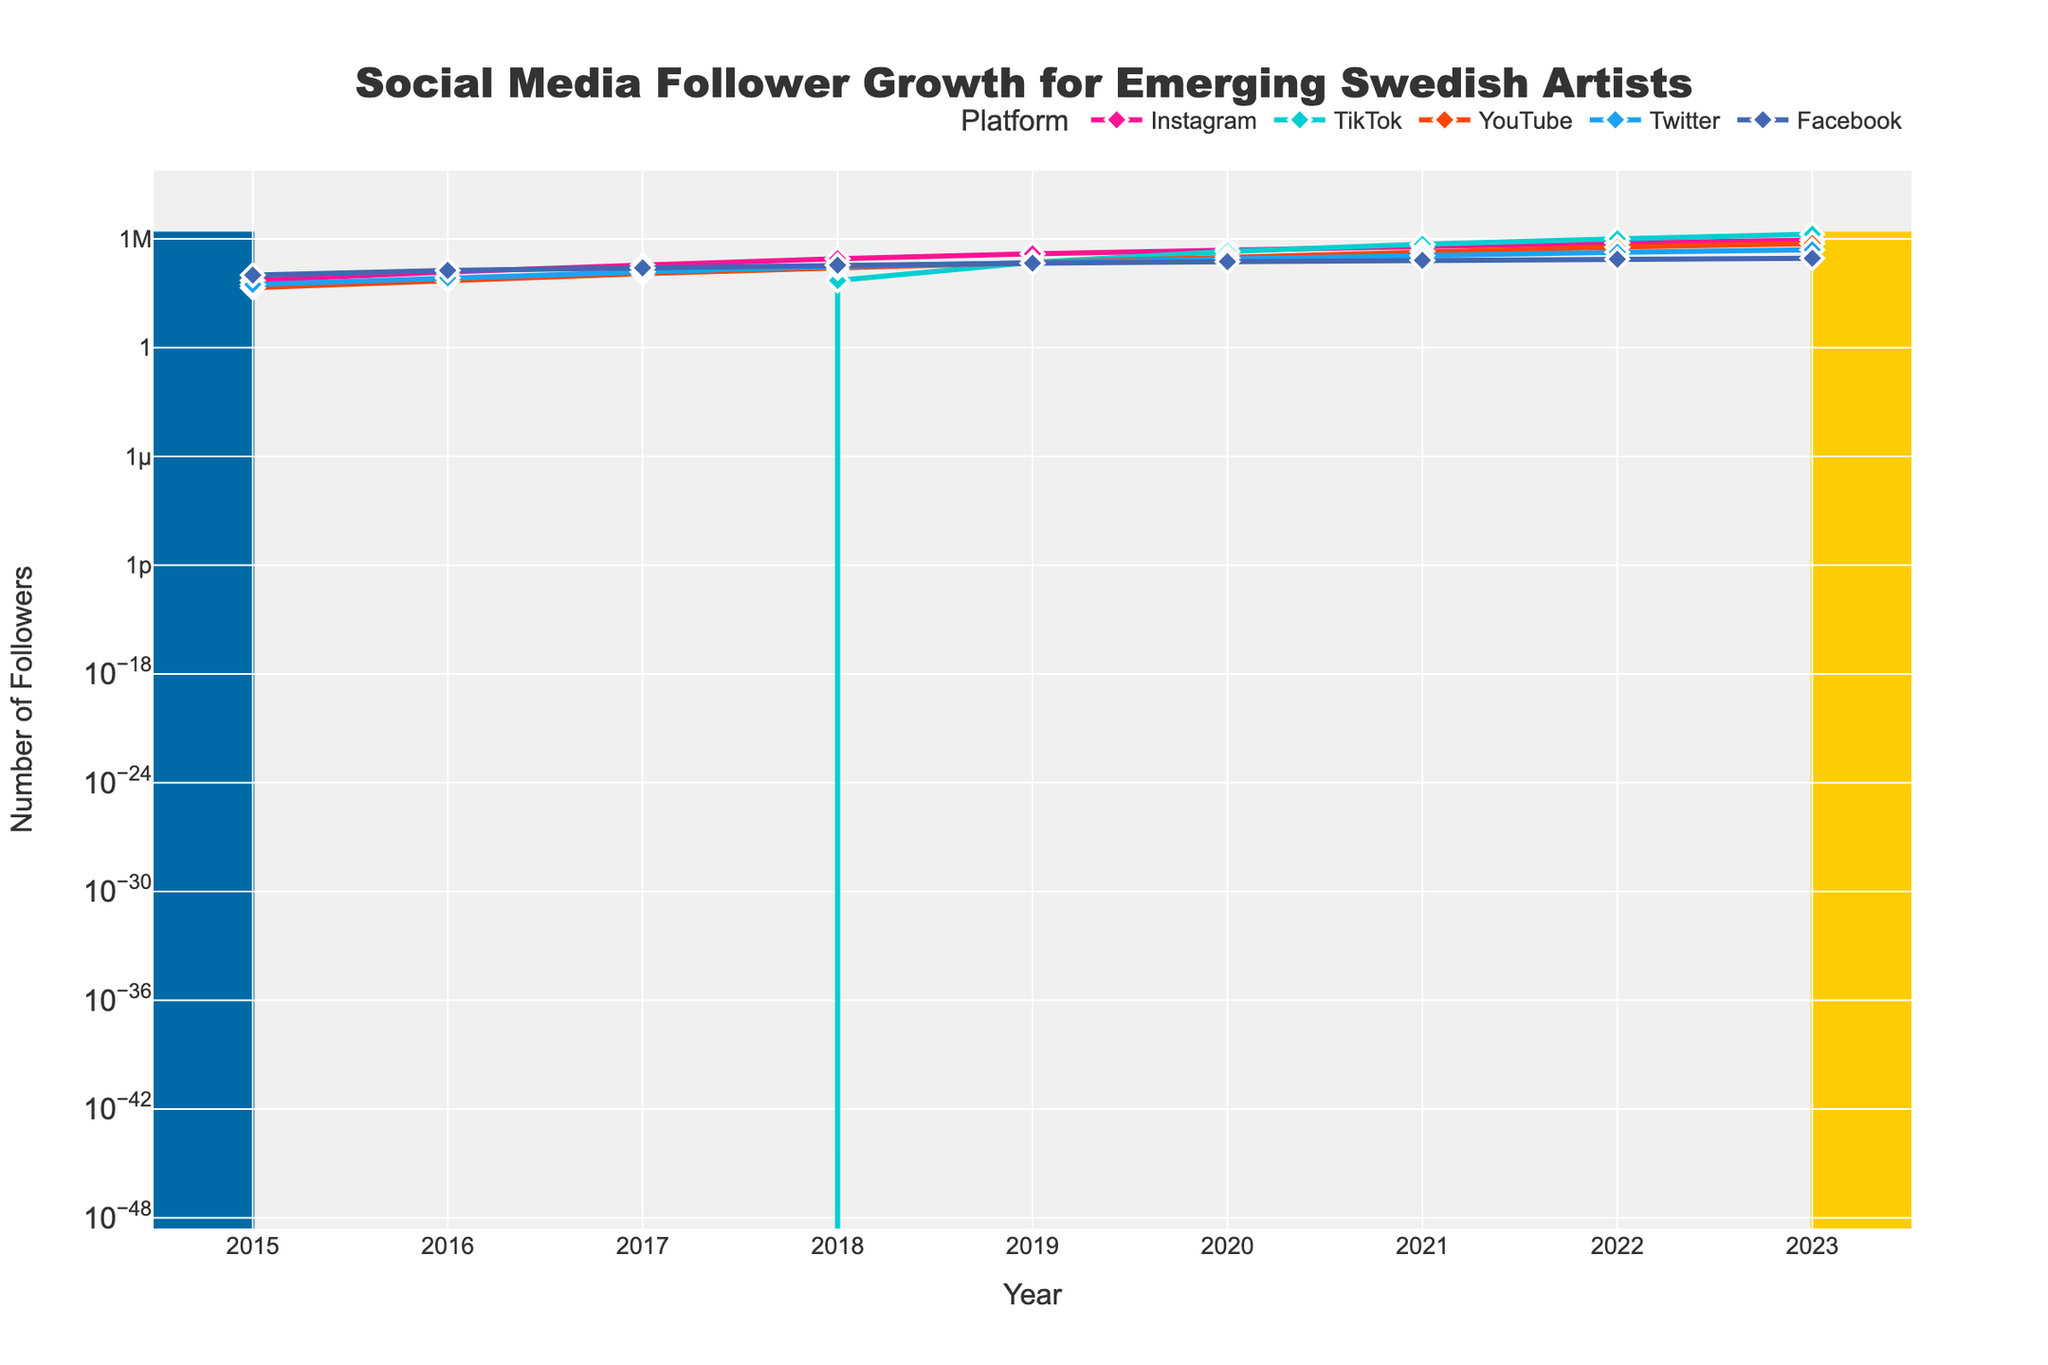What year did TikTok surpass Instagram in followers? By observing the graph, the point where the TikTok line crosses above the Instagram line signifies TikTok surpassing Instagram in followers. This crossover occurs between 2021 and 2022.
Answer: 2022 Which social media platform had the highest growth rate between 2018 and 2019? Examining the slope of the lines between 2018 and 2019, TikTok shows the steepest increase in followers, indicating the highest growth rate during that period.
Answer: TikTok By how much did YouTube followers increase from 2015 to 2023? To find the increase, subtract the number of YouTube followers in 2015 from the number in 2023: 550,000 (2023) - 2,000 (2015) = 548,000.
Answer: 548,000 Which platform had the least number of followers in 2023? From the graph, the line representing Facebook is the lowest in 2023, indicating it has the least number of followers at that time.
Answer: Facebook What is the total number of followers from all platforms in 2020? Add the number of followers for all platforms in 2020: 250,000 (Instagram) + 200,000 (TikTok) + 100,000 (YouTube) + 80,000 (Twitter) + 55,000 (Facebook) = 685,000.
Answer: 685,000 How much did Instagram followers increase from 2015 to 2022? Subtract the number of Instagram followers in 2015 from the number in 2022: 600,000 (2022) - 5,000 (2015) = 595,000.
Answer: 595,000 Which two platforms had a noticeable crossover in their follower counts between 2016 and 2019? By examining the graph, it can be seen that Twitter and YouTube have a crossover between 2016 and 2019, indicating they had similar and then differing follower counts during this period.
Answer: Twitter and YouTube Which year did Instagram have the highest absolute increase in followers? Identifying the year with the steepest slope for Instagram, the biggest jump appears between 2017 to 2018, increasing from 35,000 to 80,000 followers.
Answer: 2018 Between 2020 and 2021, which platform had the smallest increase in followers? Observing the changes between 2020 and 2021, Twitter has the smallest increase in followers as shown by the least steep line segment.
Answer: Twitter 